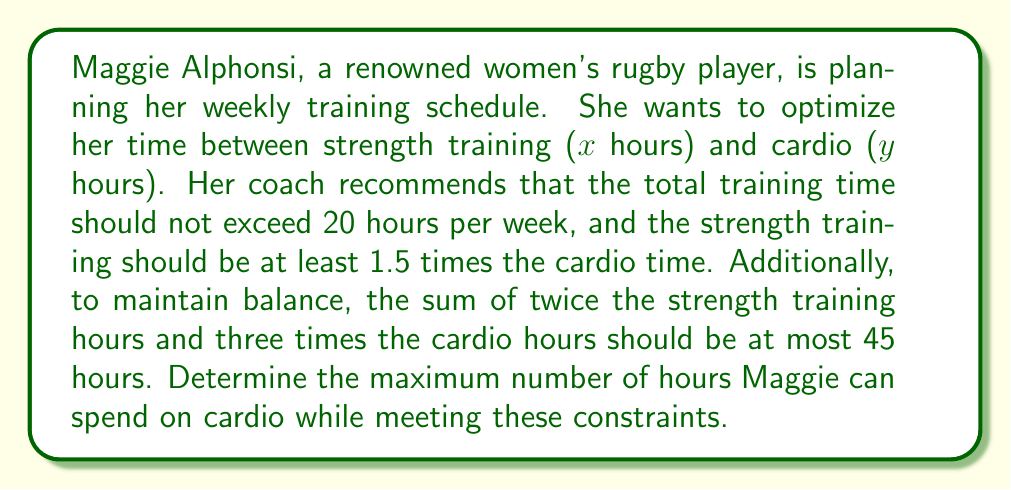Help me with this question. Let's approach this step-by-step:

1) First, let's define our variables:
   x = hours of strength training
   y = hours of cardio

2) Now, we can set up our system of inequalities based on the given constraints:

   a) Total training time: $x + y \leq 20$
   b) Strength training at least 1.5 times cardio: $x \geq 1.5y$
   c) Balance constraint: $2x + 3y \leq 45$
   d) Non-negativity constraints: $x \geq 0, y \geq 0$

3) We want to maximize y (cardio hours) while satisfying these constraints.

4) From constraint (b), we can derive: $x = 1.5y$

5) Substituting this into constraint (a):
   $1.5y + y \leq 20$
   $2.5y \leq 20$
   $y \leq 8$

6) Now, let's check if this satisfies constraint (c):
   $2(1.5y) + 3y \leq 45$
   $3y + 3y \leq 45$
   $6y \leq 45$
   $y \leq 7.5$

7) Therefore, the maximum value for y that satisfies all constraints is 7.5 hours.

8) We can verify:
   If y = 7.5, then x = 1.5(7.5) = 11.25
   x + y = 11.25 + 7.5 = 18.75 ≤ 20 (satisfies constraint a)
   x = 11.25 > 1.5(7.5) = 11.25 (satisfies constraint b)
   2x + 3y = 2(11.25) + 3(7.5) = 22.5 + 22.5 = 45 ≤ 45 (satisfies constraint c)
Answer: 7.5 hours 